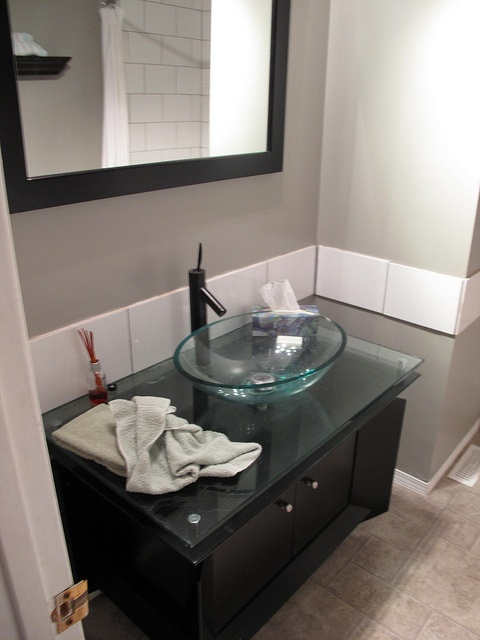Describe the objects in this image and their specific colors. I can see a sink in black, gray, darkgray, and teal tones in this image. 